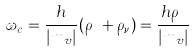<formula> <loc_0><loc_0><loc_500><loc_500>\omega _ { c } = \frac { h } { | m _ { v } | } ( \rho _ { _ { B } } + \rho _ { \nu } ) = \frac { h \rho _ { _ { B } } } { | m _ { v } | }</formula> 